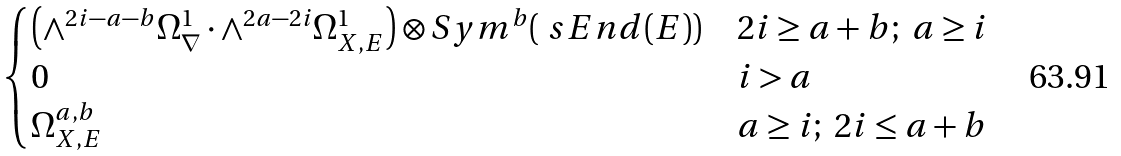Convert formula to latex. <formula><loc_0><loc_0><loc_500><loc_500>\begin{cases} \left ( \wedge ^ { 2 i - a - b } \Omega ^ { 1 } _ { \nabla } \cdot \wedge ^ { 2 a - 2 i } \Omega ^ { 1 } _ { X , E } \right ) \otimes S y m ^ { b } ( \ s E n d ( E ) ) & 2 i \geq a + b ; \ a \geq i \\ 0 & i > a \\ \Omega ^ { a , b } _ { X , E } & a \geq i ; \ 2 i \leq a + b \end{cases}</formula> 